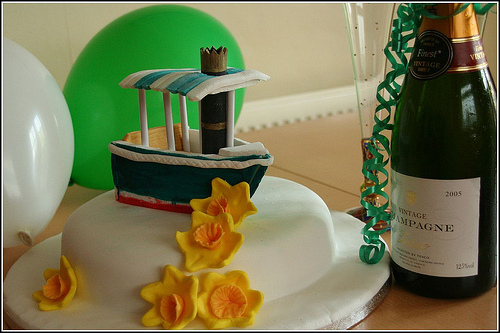<image>
Can you confirm if the ribbon is on the bottle? Yes. Looking at the image, I can see the ribbon is positioned on top of the bottle, with the bottle providing support. 